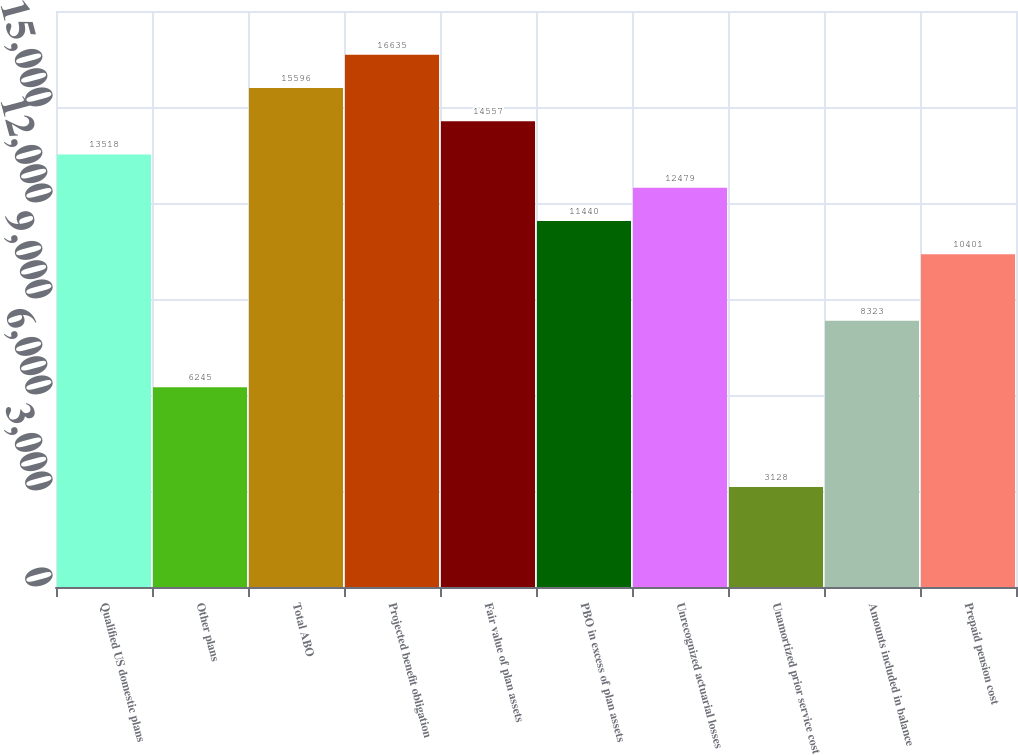<chart> <loc_0><loc_0><loc_500><loc_500><bar_chart><fcel>Qualified US domestic plans<fcel>Other plans<fcel>Total ABO<fcel>Projected benefit obligation<fcel>Fair value of plan assets<fcel>PBO in excess of plan assets<fcel>Unrecognized actuarial losses<fcel>Unamortized prior service cost<fcel>Amounts included in balance<fcel>Prepaid pension cost<nl><fcel>13518<fcel>6245<fcel>15596<fcel>16635<fcel>14557<fcel>11440<fcel>12479<fcel>3128<fcel>8323<fcel>10401<nl></chart> 